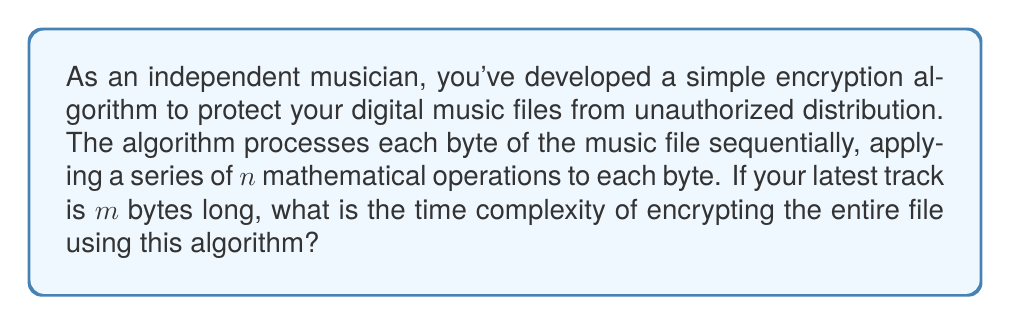Can you answer this question? To determine the time complexity of the encryption algorithm, we need to analyze how the number of operations grows with respect to the input size. Let's break it down step-by-step:

1. The algorithm processes each byte of the music file individually.
2. For each byte, it applies $n$ mathematical operations.
3. The music file is $m$ bytes long.

Therefore:
1. The algorithm will process $m$ bytes in total.
2. For each of these $m$ bytes, it performs $n$ operations.
3. The total number of operations performed is thus $m \times n$.

In Big O notation, we express this as $O(mn)$.

However, we need to consider that $n$ is a constant value (the number of operations doesn't change based on the file size). In asymptotic analysis, we typically focus on how the algorithm scales with respect to the input size ($m$ in this case) and ignore constant factors.

As $n$ is constant, we can simplify the time complexity to $O(m)$.

This means the time complexity of the encryption algorithm grows linearly with the size of the music file. As the file size doubles, the time to encrypt it will also approximately double.
Answer: $O(m)$ 